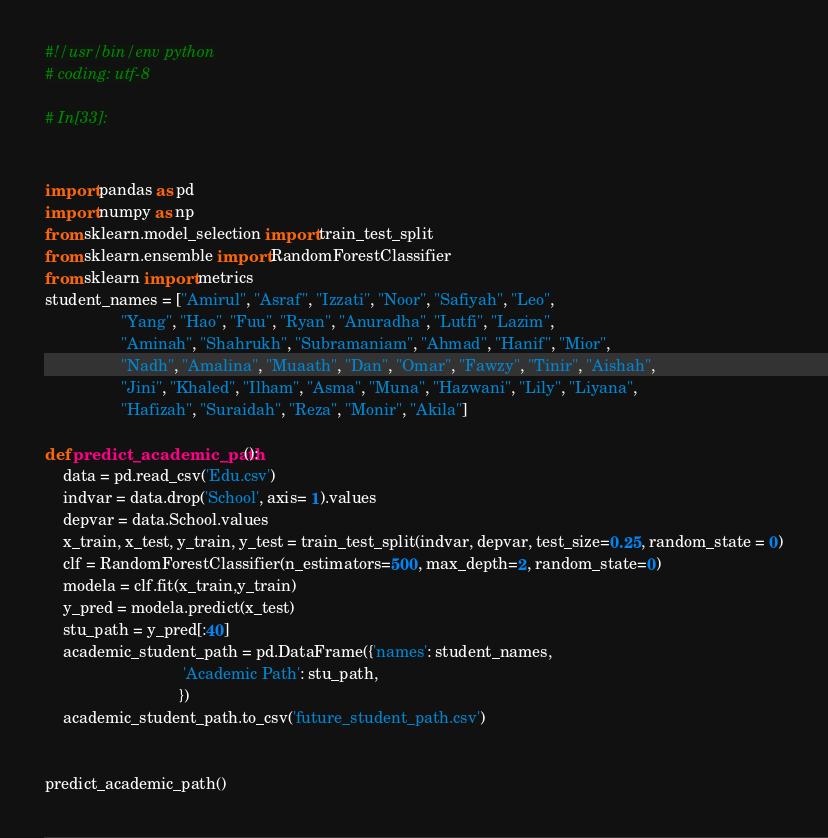Convert code to text. <code><loc_0><loc_0><loc_500><loc_500><_Python_>#!/usr/bin/env python
# coding: utf-8

# In[33]:


import pandas as pd
import numpy as np
from sklearn.model_selection import train_test_split
from sklearn.ensemble import RandomForestClassifier
from sklearn import metrics
student_names = ["Amirul", "Asraf", "Izzati", "Noor", "Safiyah", "Leo", 
                 "Yang", "Hao", "Fuu", "Ryan", "Anuradha", "Lutfi", "Lazim",
                 "Aminah", "Shahrukh", "Subramaniam", "Ahmad", "Hanif", "Mior",
                 "Nadh", "Amalina", "Muaath", "Dan", "Omar", "Fawzy", "Tinir", "Aishah",
                 "Jini", "Khaled", "Ilham", "Asma", "Muna", "Hazwani", "Lily", "Liyana",
                 "Hafizah", "Suraidah", "Reza", "Monir", "Akila"]

def predict_academic_path():
    data = pd.read_csv('Edu.csv')
    indvar = data.drop('School', axis= 1).values
    depvar = data.School.values
    x_train, x_test, y_train, y_test = train_test_split(indvar, depvar, test_size=0.25, random_state = 0)
    clf = RandomForestClassifier(n_estimators=500, max_depth=2, random_state=0)
    modela = clf.fit(x_train,y_train)
    y_pred = modela.predict(x_test)
    stu_path = y_pred[:40]
    academic_student_path = pd.DataFrame({'names': student_names,
                               'Academic Path': stu_path,
                              })
    academic_student_path.to_csv('future_student_path.csv')
    

predict_academic_path()




</code> 